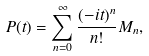<formula> <loc_0><loc_0><loc_500><loc_500>P ( t ) = \sum _ { n = 0 } ^ { \infty } \frac { ( - i t ) ^ { n } } { n ! } M _ { n } ,</formula> 